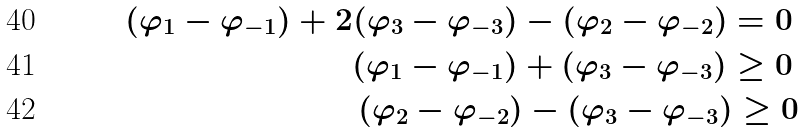<formula> <loc_0><loc_0><loc_500><loc_500>( \varphi _ { 1 } - \varphi _ { - 1 } ) + 2 ( \varphi _ { 3 } - \varphi _ { - 3 } ) - ( \varphi _ { 2 } - \varphi _ { - 2 } ) = 0 \, \\ ( \varphi _ { 1 } - \varphi _ { - 1 } ) + ( \varphi _ { 3 } - \varphi _ { - 3 } ) \geq 0 \, \\ ( \varphi _ { 2 } - \varphi _ { - 2 } ) - ( \varphi _ { 3 } - \varphi _ { - 3 } ) \geq 0</formula> 